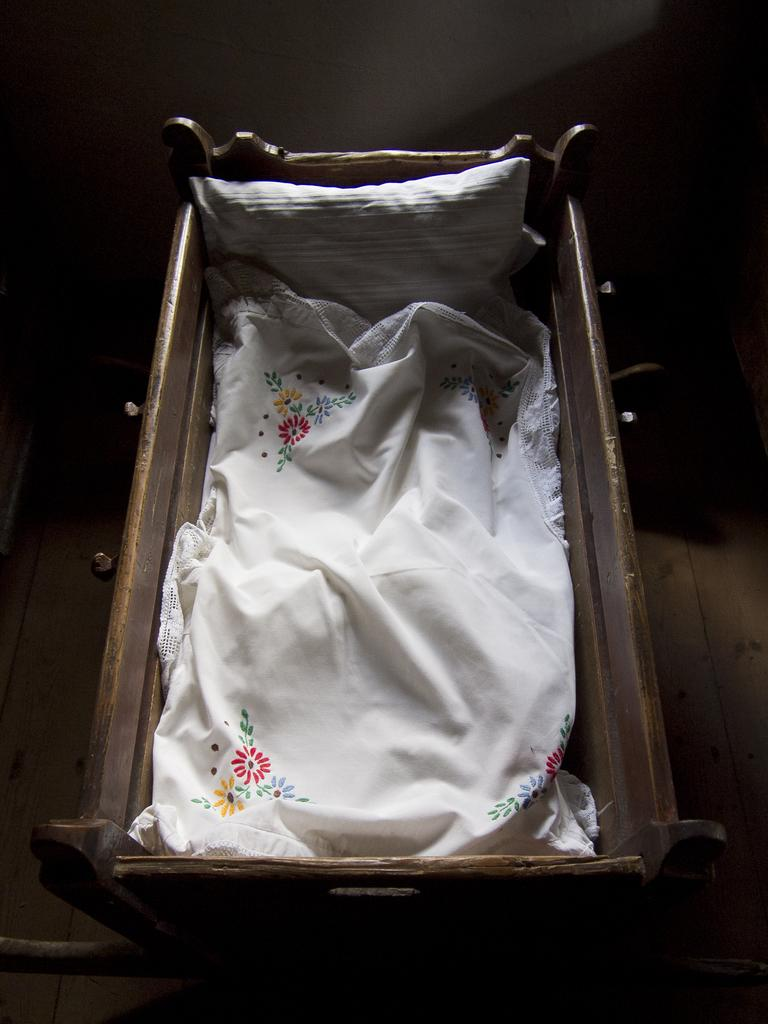What type of furniture is in the image? There is a wooden swing in the image. Where is the wooden swing located? The wooden swing is on the floor. What is placed on the wooden swing? There is a pillow on the swing. What type of fabric is used on the swing? There is a designed white color cloth on the swing. What type of eggnog is being served on the wooden swing? There is no eggnog present in the image; it features a wooden swing with a pillow and a designed white color cloth. 